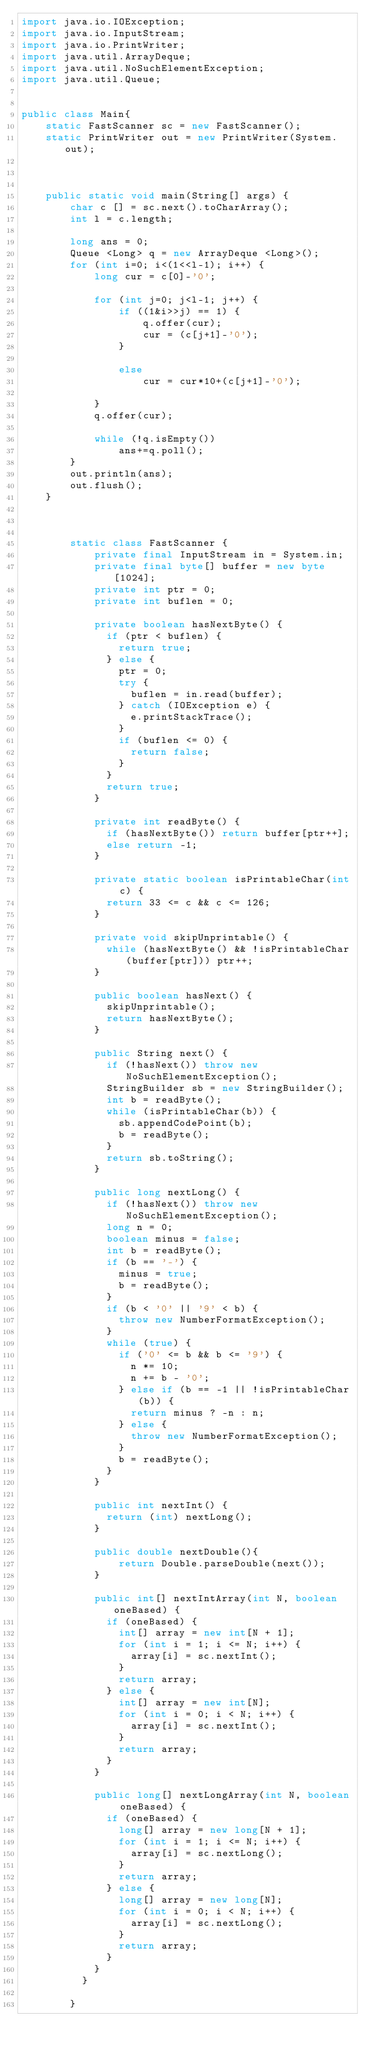<code> <loc_0><loc_0><loc_500><loc_500><_Java_>import java.io.IOException;
import java.io.InputStream;
import java.io.PrintWriter;
import java.util.ArrayDeque;
import java.util.NoSuchElementException;
import java.util.Queue;


public class Main{
	static FastScanner sc = new FastScanner();
	static PrintWriter out = new PrintWriter(System.out);
	
	

	public static void main(String[] args) {
		char c [] = sc.next().toCharArray();
		int l = c.length;
		
		long ans = 0;
		Queue <Long> q = new ArrayDeque <Long>();
		for (int i=0; i<(1<<l-1); i++) {
			long cur = c[0]-'0';
			
			for (int j=0; j<l-1; j++) {
				if ((1&i>>j) == 1) {
					q.offer(cur);
					cur = (c[j+1]-'0');
				}
				
				else 
					cur = cur*10+(c[j+1]-'0');
				
			}
			q.offer(cur);
			
			while (!q.isEmpty())
				ans+=q.poll();
		}
		out.println(ans);
		out.flush();
	}
	
	
	
		static class FastScanner {
		    private final InputStream in = System.in;
		    private final byte[] buffer = new byte[1024];
		    private int ptr = 0;
		    private int buflen = 0;

		    private boolean hasNextByte() {
		      if (ptr < buflen) {
		        return true;
		      } else {
		        ptr = 0;
		        try {
		          buflen = in.read(buffer);
		        } catch (IOException e) {
		          e.printStackTrace();
		        }
		        if (buflen <= 0) {
		          return false;
		        }
		      }
		      return true;
		    }

		    private int readByte() {
		      if (hasNextByte()) return buffer[ptr++];
		      else return -1;
		    }

		    private static boolean isPrintableChar(int c) {
		      return 33 <= c && c <= 126;
		    }

		    private void skipUnprintable() {
		      while (hasNextByte() && !isPrintableChar(buffer[ptr])) ptr++;
		    }

		    public boolean hasNext() {
		      skipUnprintable();
		      return hasNextByte();
		    }

		    public String next() {
		      if (!hasNext()) throw new NoSuchElementException();
		      StringBuilder sb = new StringBuilder();
		      int b = readByte();
		      while (isPrintableChar(b)) {
		        sb.appendCodePoint(b);
		        b = readByte();
		      }
		      return sb.toString();
		    }

		    public long nextLong() {
		      if (!hasNext()) throw new NoSuchElementException();
		      long n = 0;
		      boolean minus = false;
		      int b = readByte();
		      if (b == '-') {
		        minus = true;
		        b = readByte();
		      }
		      if (b < '0' || '9' < b) {
		        throw new NumberFormatException();
		      }
		      while (true) {
		        if ('0' <= b && b <= '9') {
		          n *= 10;
		          n += b - '0';
		        } else if (b == -1 || !isPrintableChar(b)) {
		          return minus ? -n : n;
		        } else {
		          throw new NumberFormatException();
		        }
		        b = readByte();
		      }
		    }

		    public int nextInt() {
		      return (int) nextLong();
		    }
		    
		    public double nextDouble(){
		    	return Double.parseDouble(next());
		    }

		    public int[] nextIntArray(int N, boolean oneBased) {
		      if (oneBased) {
		        int[] array = new int[N + 1];
		        for (int i = 1; i <= N; i++) {
		          array[i] = sc.nextInt();
		        }
		        return array;
		      } else {
		        int[] array = new int[N];
		        for (int i = 0; i < N; i++) {
		          array[i] = sc.nextInt();
		        }
		        return array;
		      }
		    }

		    public long[] nextLongArray(int N, boolean oneBased) {
		      if (oneBased) {
		        long[] array = new long[N + 1];
		        for (int i = 1; i <= N; i++) {
		          array[i] = sc.nextLong();
		        }
		        return array;
		      } else {
		        long[] array = new long[N];
		        for (int i = 0; i < N; i++) {
		          array[i] = sc.nextLong();
		        }
		        return array;
		      }
		    }
		  }

		}	 



</code> 